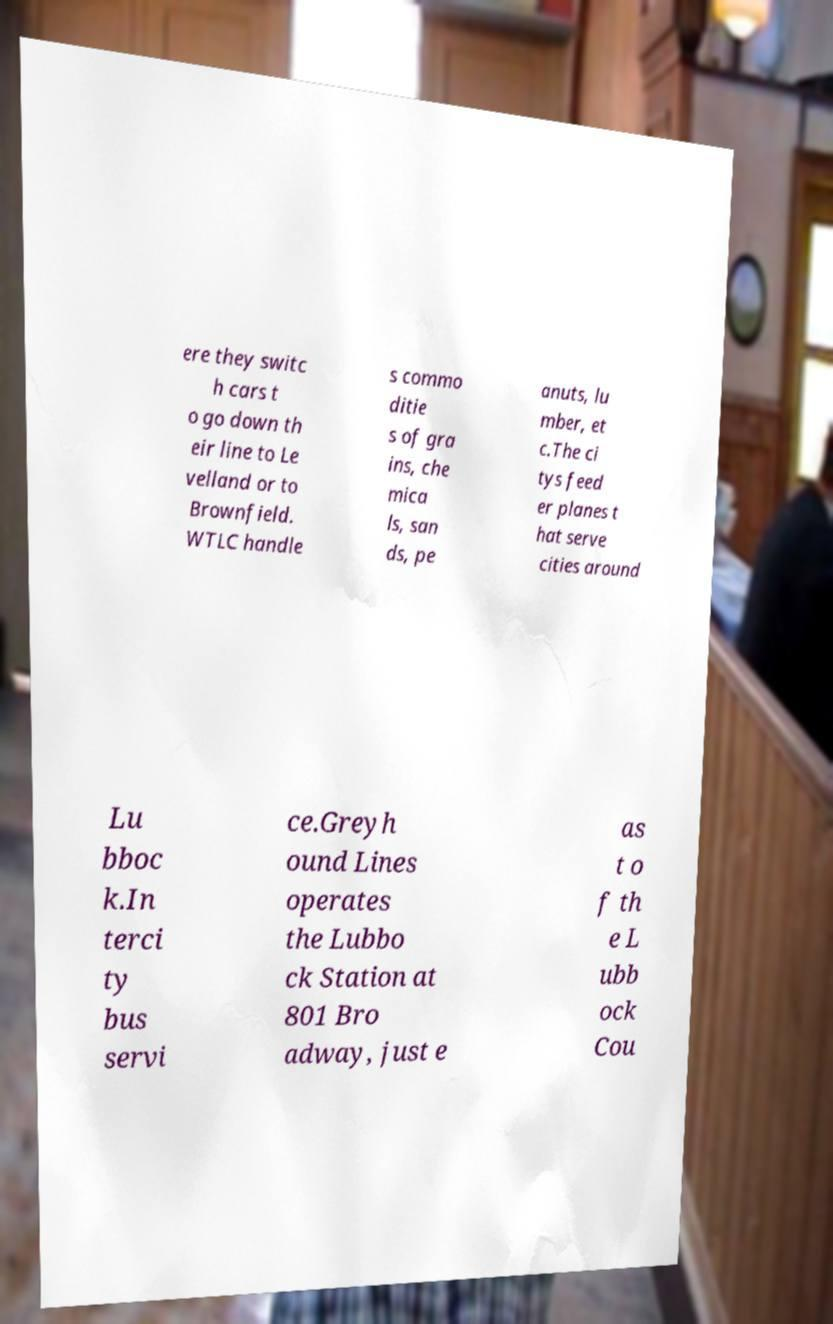Can you accurately transcribe the text from the provided image for me? ere they switc h cars t o go down th eir line to Le velland or to Brownfield. WTLC handle s commo ditie s of gra ins, che mica ls, san ds, pe anuts, lu mber, et c.The ci tys feed er planes t hat serve cities around Lu bboc k.In terci ty bus servi ce.Greyh ound Lines operates the Lubbo ck Station at 801 Bro adway, just e as t o f th e L ubb ock Cou 